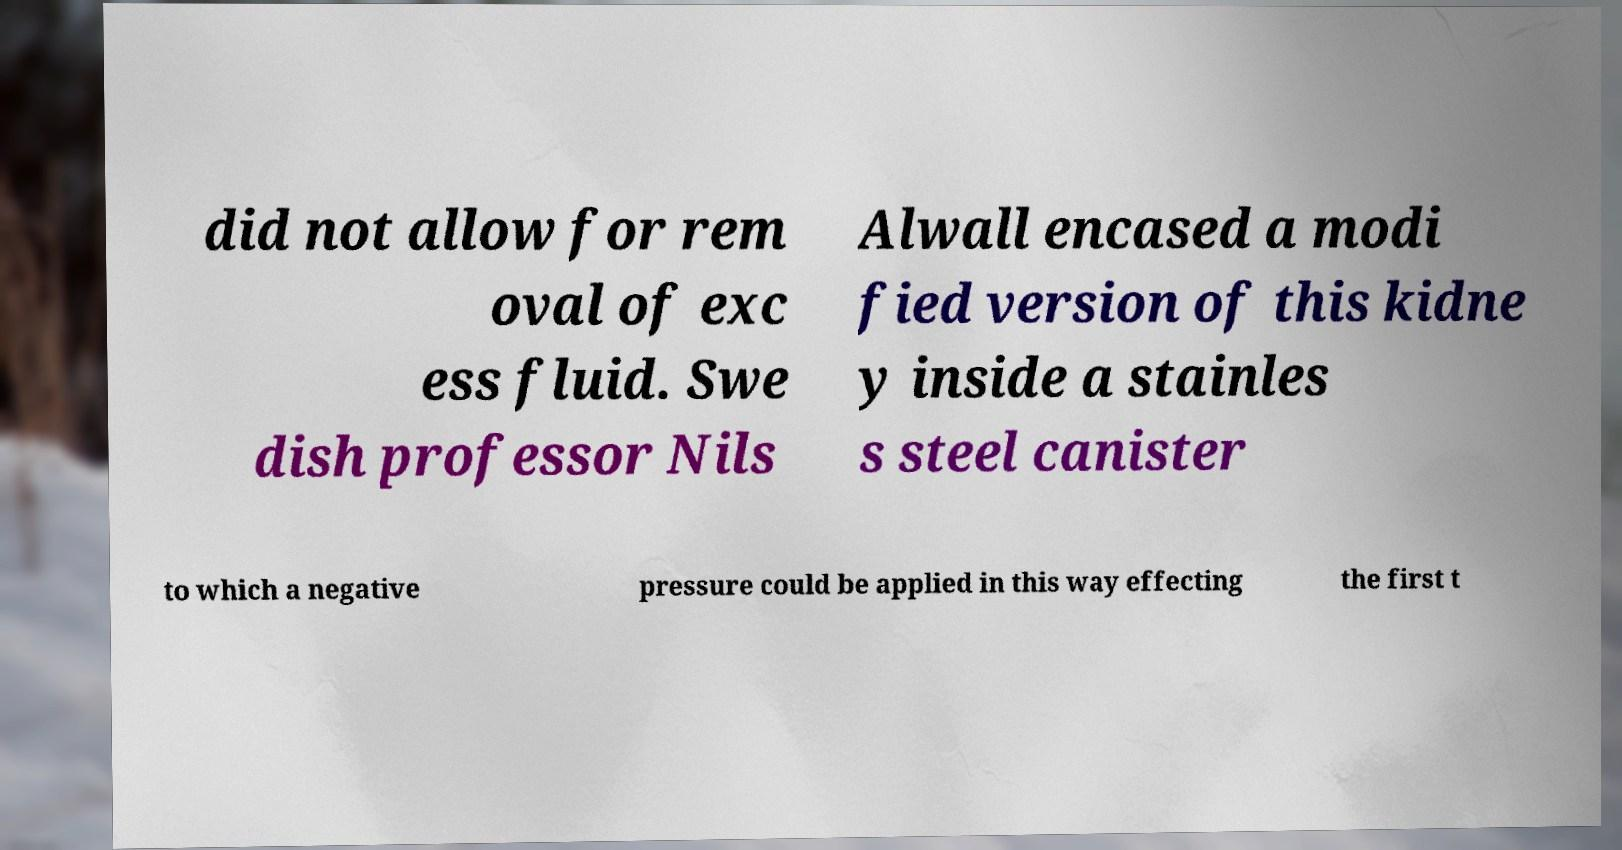There's text embedded in this image that I need extracted. Can you transcribe it verbatim? did not allow for rem oval of exc ess fluid. Swe dish professor Nils Alwall encased a modi fied version of this kidne y inside a stainles s steel canister to which a negative pressure could be applied in this way effecting the first t 